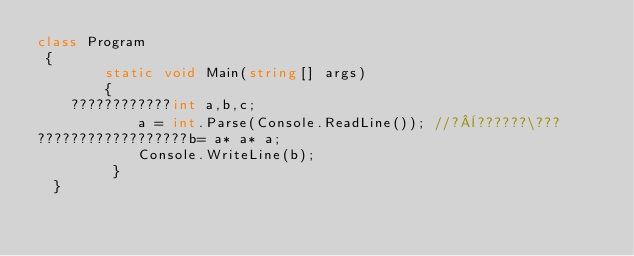<code> <loc_0><loc_0><loc_500><loc_500><_C#_>class Program
 {
        static void Main(string[] args)
        {
    ????????????int a,b,c;
            a = int.Parse(Console.ReadLine()); //?¨??????\???
??????????????????b= a* a* a;
            Console.WriteLine(b);
         }
  }</code> 